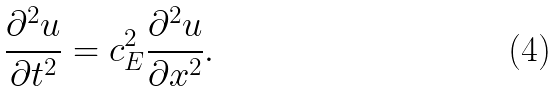<formula> <loc_0><loc_0><loc_500><loc_500>\frac { \partial ^ { 2 } u } { \partial t ^ { 2 } } = c _ { E } ^ { 2 } \frac { \partial ^ { 2 } u } { \partial x ^ { 2 } } .</formula> 